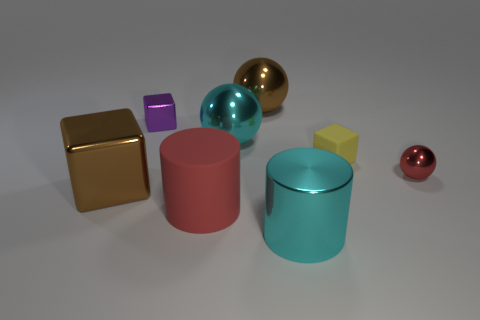Add 1 tiny purple rubber blocks. How many objects exist? 9 Subtract all balls. How many objects are left? 5 Subtract 1 cyan cylinders. How many objects are left? 7 Subtract all big purple metallic cubes. Subtract all large metallic things. How many objects are left? 4 Add 4 tiny objects. How many tiny objects are left? 7 Add 8 large yellow metal cylinders. How many large yellow metal cylinders exist? 8 